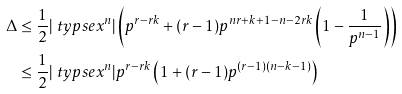<formula> <loc_0><loc_0><loc_500><loc_500>\Delta & \leq \frac { 1 } { 2 } | \ t y p s e { x ^ { n } } | \left ( p ^ { r - r k } + ( r - 1 ) p ^ { n r + k + 1 - n - 2 r k } \left ( 1 - \frac { 1 } { p ^ { n - 1 } } \right ) \right ) \\ & \leq \frac { 1 } { 2 } | \ t y p s e { x ^ { n } } | p ^ { r - r k } \left ( 1 + ( r - 1 ) p ^ { ( r - 1 ) ( n - k - 1 ) } \right )</formula> 